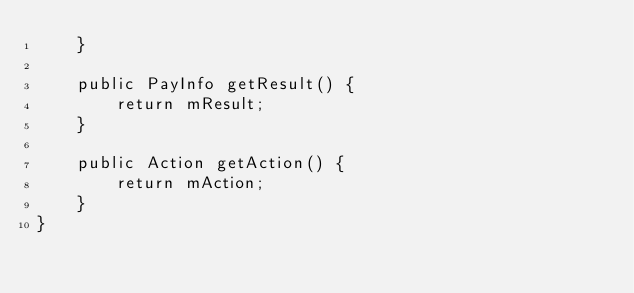<code> <loc_0><loc_0><loc_500><loc_500><_Java_>    }

    public PayInfo getResult() {
        return mResult;
    }

    public Action getAction() {
        return mAction;
    }
}
</code> 